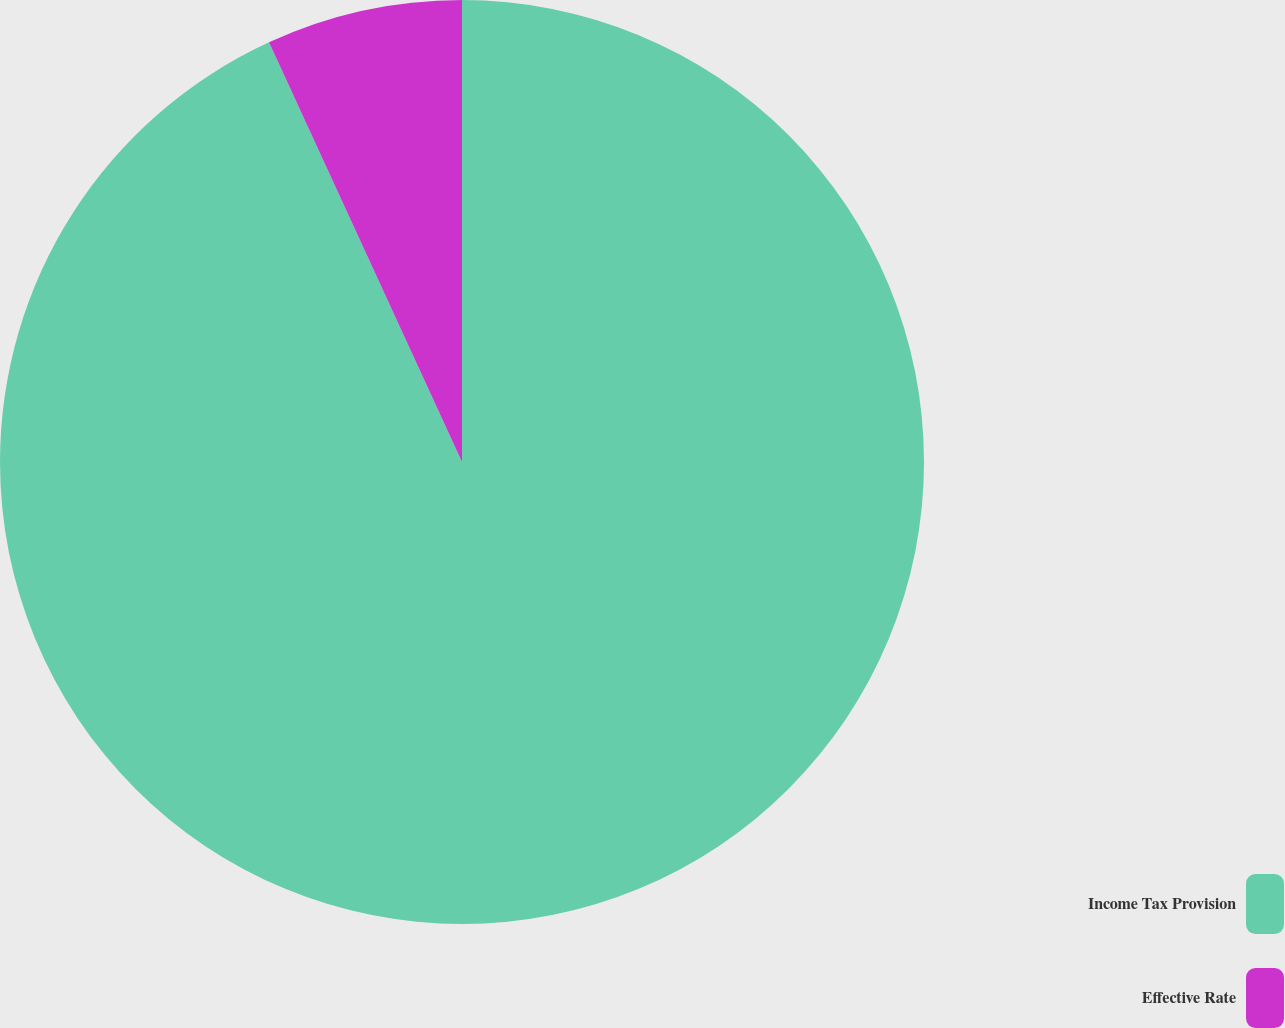Convert chart. <chart><loc_0><loc_0><loc_500><loc_500><pie_chart><fcel>Income Tax Provision<fcel>Effective Rate<nl><fcel>93.14%<fcel>6.86%<nl></chart> 